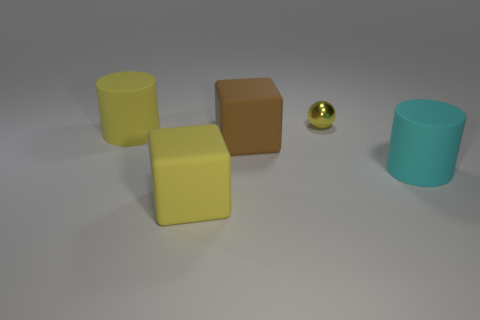The other matte cylinder that is the same size as the cyan cylinder is what color?
Provide a short and direct response. Yellow. Does the cyan cylinder have the same material as the yellow cylinder?
Provide a succinct answer. Yes. There is a large yellow object behind the big cylinder that is to the right of the small metallic ball; what is its material?
Give a very brief answer. Rubber. Are there more objects that are behind the large yellow cube than blue metal cubes?
Your answer should be compact. Yes. How many other objects are there of the same size as the metal sphere?
Provide a short and direct response. 0. The cylinder that is in front of the big cylinder that is behind the big matte thing that is right of the yellow metal object is what color?
Your answer should be compact. Cyan. There is a matte cube behind the yellow matte thing in front of the large brown matte cube; how many cylinders are in front of it?
Offer a very short reply. 1. There is a thing on the right side of the ball; does it have the same size as the large brown rubber cube?
Offer a very short reply. Yes. What number of big cyan objects are in front of the large rubber object behind the brown matte cube?
Make the answer very short. 1. Are there any yellow rubber cylinders to the left of the large matte cylinder on the left side of the big cylinder that is in front of the big brown rubber block?
Ensure brevity in your answer.  No. 